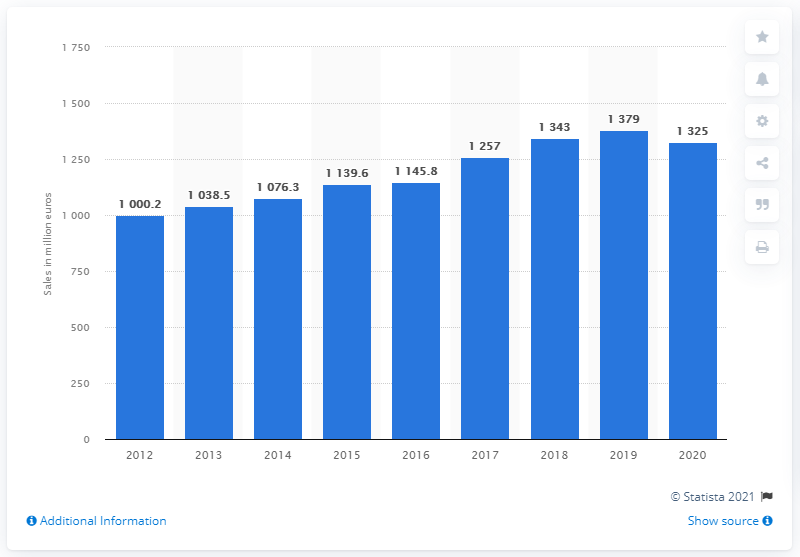Draw attention to some important aspects in this diagram. In 2020, Tesa's global sales were 1,325. Tesa's global sales from a year earlier were 1,379. 